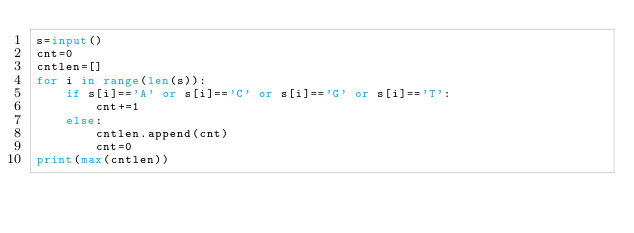Convert code to text. <code><loc_0><loc_0><loc_500><loc_500><_Python_>s=input()
cnt=0
cntlen=[]
for i in range(len(s)):
    if s[i]=='A' or s[i]=='C' or s[i]=='G' or s[i]=='T':
        cnt+=1
    else:
        cntlen.append(cnt)
        cnt=0
print(max(cntlen))</code> 